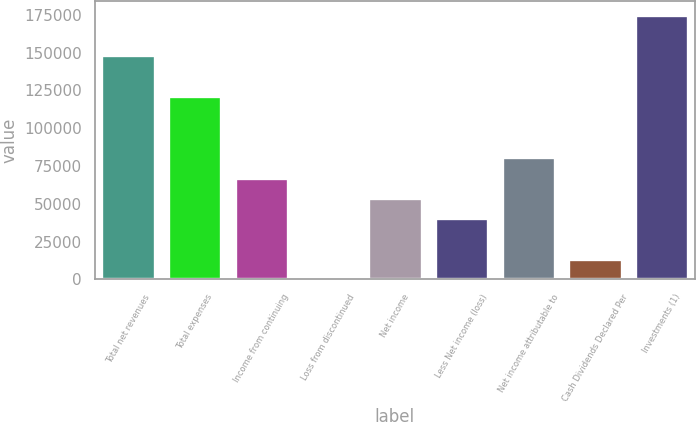Convert chart to OTSL. <chart><loc_0><loc_0><loc_500><loc_500><bar_chart><fcel>Total net revenues<fcel>Total expenses<fcel>Income from continuing<fcel>Loss from discontinued<fcel>Net income<fcel>Less Net income (loss)<fcel>Net income attributable to<fcel>Cash Dividends Declared Per<fcel>Investments (1)<nl><fcel>148202<fcel>121256<fcel>67364.5<fcel>0.01<fcel>53891.6<fcel>40418.7<fcel>80837.4<fcel>13472.9<fcel>175148<nl></chart> 